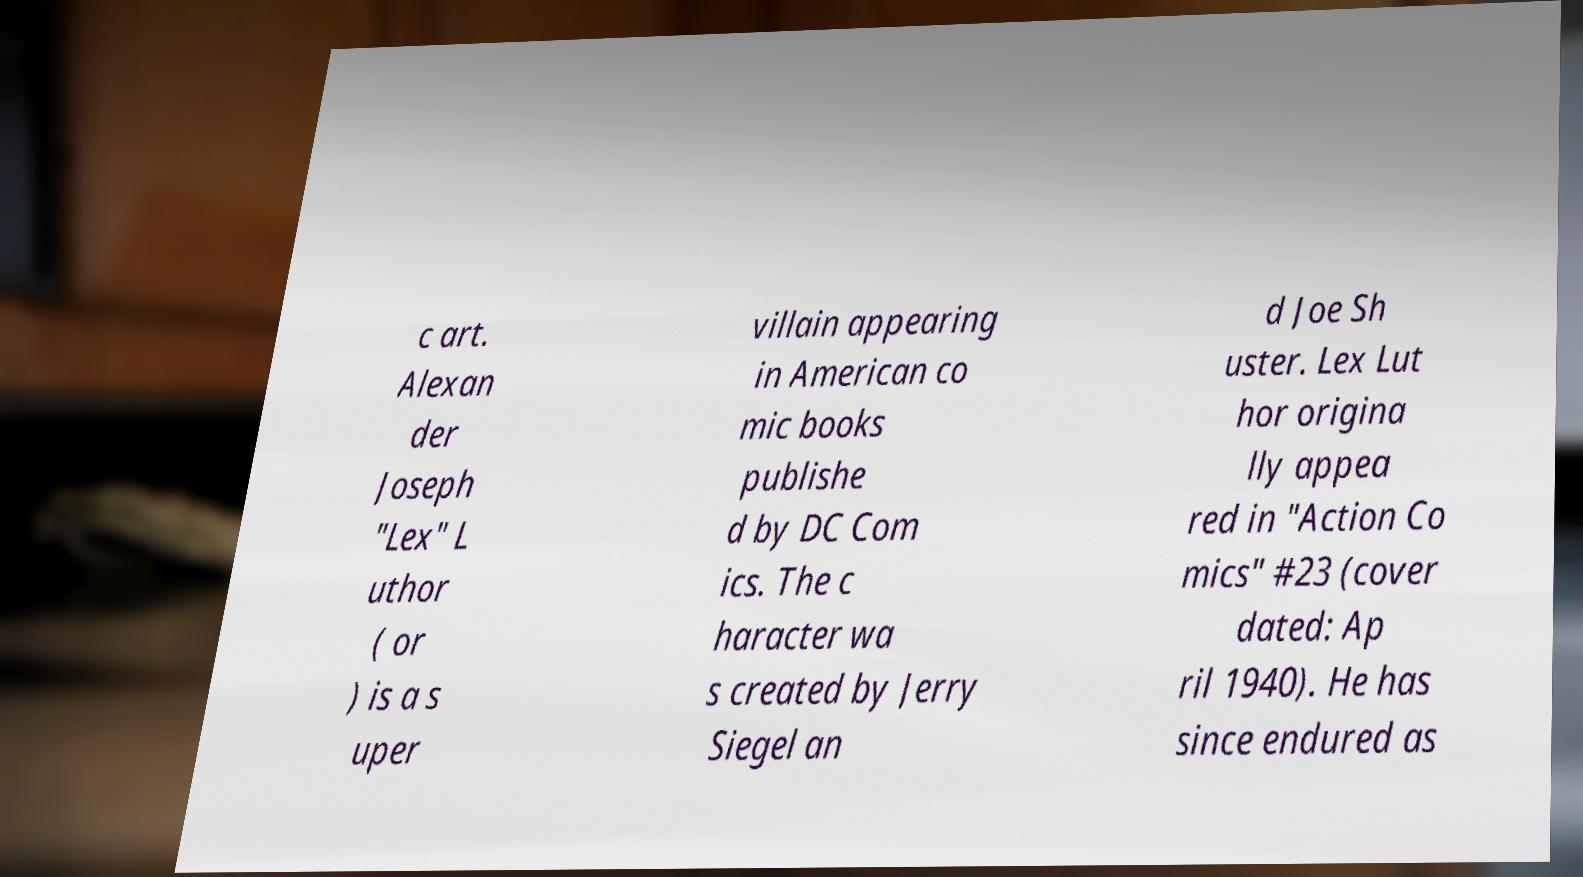There's text embedded in this image that I need extracted. Can you transcribe it verbatim? c art. Alexan der Joseph "Lex" L uthor ( or ) is a s uper villain appearing in American co mic books publishe d by DC Com ics. The c haracter wa s created by Jerry Siegel an d Joe Sh uster. Lex Lut hor origina lly appea red in "Action Co mics" #23 (cover dated: Ap ril 1940). He has since endured as 